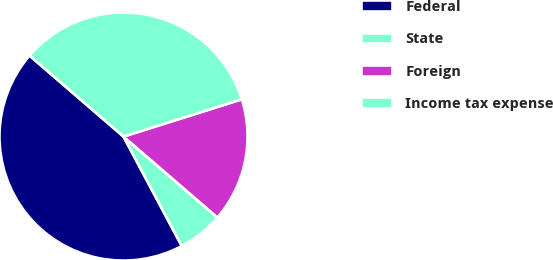Convert chart. <chart><loc_0><loc_0><loc_500><loc_500><pie_chart><fcel>Federal<fcel>State<fcel>Foreign<fcel>Income tax expense<nl><fcel>44.11%<fcel>5.89%<fcel>16.18%<fcel>33.82%<nl></chart> 